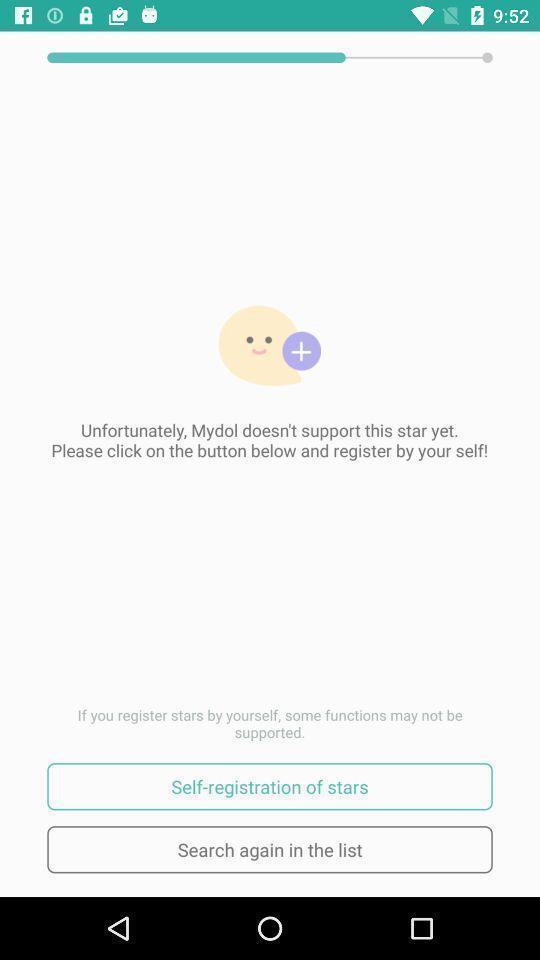Describe this image in words. Self registration for the stars in the application. 